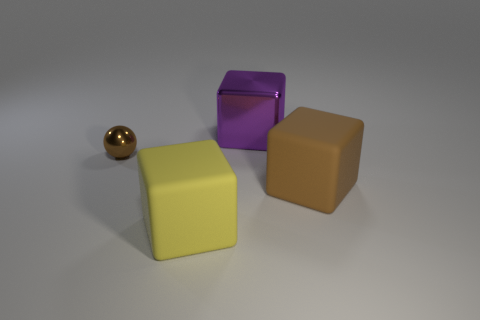Is there anything else that is the same size as the brown shiny thing?
Offer a terse response. No. There is a brown thing that is the same shape as the yellow object; what material is it?
Your answer should be compact. Rubber. What is the shape of the big brown thing?
Your answer should be compact. Cube. Is there any other thing that has the same material as the big yellow object?
Provide a succinct answer. Yes. Is the material of the big brown cube the same as the big yellow block?
Provide a succinct answer. Yes. There is a rubber object that is left of the thing behind the brown ball; is there a purple metal cube behind it?
Your answer should be compact. Yes. How many other objects are the same shape as the yellow thing?
Your answer should be compact. 2. There is a object that is behind the brown rubber thing and right of the small brown metallic object; what shape is it?
Make the answer very short. Cube. What is the color of the cube that is in front of the brown object to the right of the yellow rubber block that is to the left of the brown matte thing?
Your response must be concise. Yellow. Are there more small balls that are right of the big yellow cube than large matte blocks that are in front of the big brown matte block?
Make the answer very short. No. 